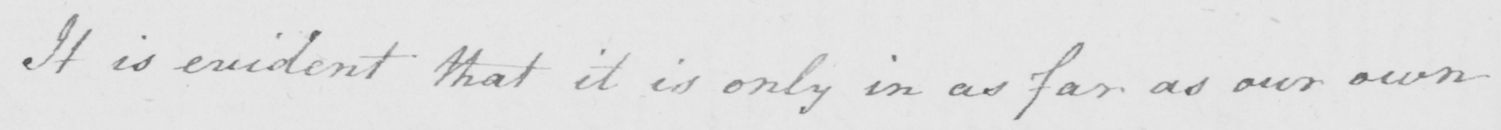Please transcribe the handwritten text in this image. It is evident that it is only in as far as our own 